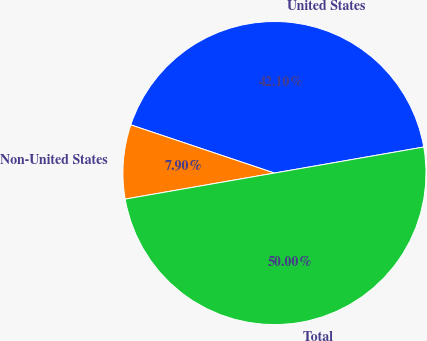<chart> <loc_0><loc_0><loc_500><loc_500><pie_chart><fcel>United States<fcel>Non-United States<fcel>Total<nl><fcel>42.1%<fcel>7.9%<fcel>50.0%<nl></chart> 